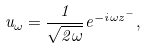<formula> <loc_0><loc_0><loc_500><loc_500>u _ { \omega } = \frac { 1 } { \sqrt { 2 \omega } } e ^ { - i \omega z ^ { - } } ,</formula> 